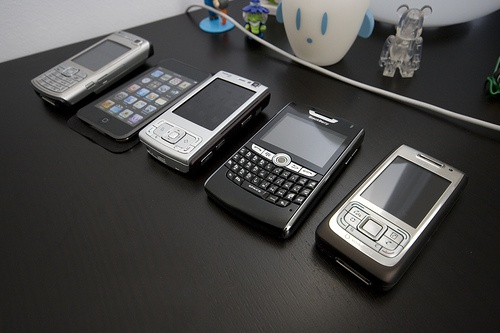Describe the objects in this image and their specific colors. I can see dining table in black, darkgray, and gray tones, cell phone in darkgray, black, lightgray, and gray tones, cell phone in darkgray, black, gray, and lightgray tones, cell phone in darkgray, gray, lightgray, and black tones, and cell phone in darkgray, gray, and black tones in this image. 